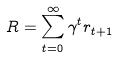Convert formula to latex. <formula><loc_0><loc_0><loc_500><loc_500>R = \sum _ { t = 0 } ^ { \infty } \gamma ^ { t } r _ { t + 1 }</formula> 